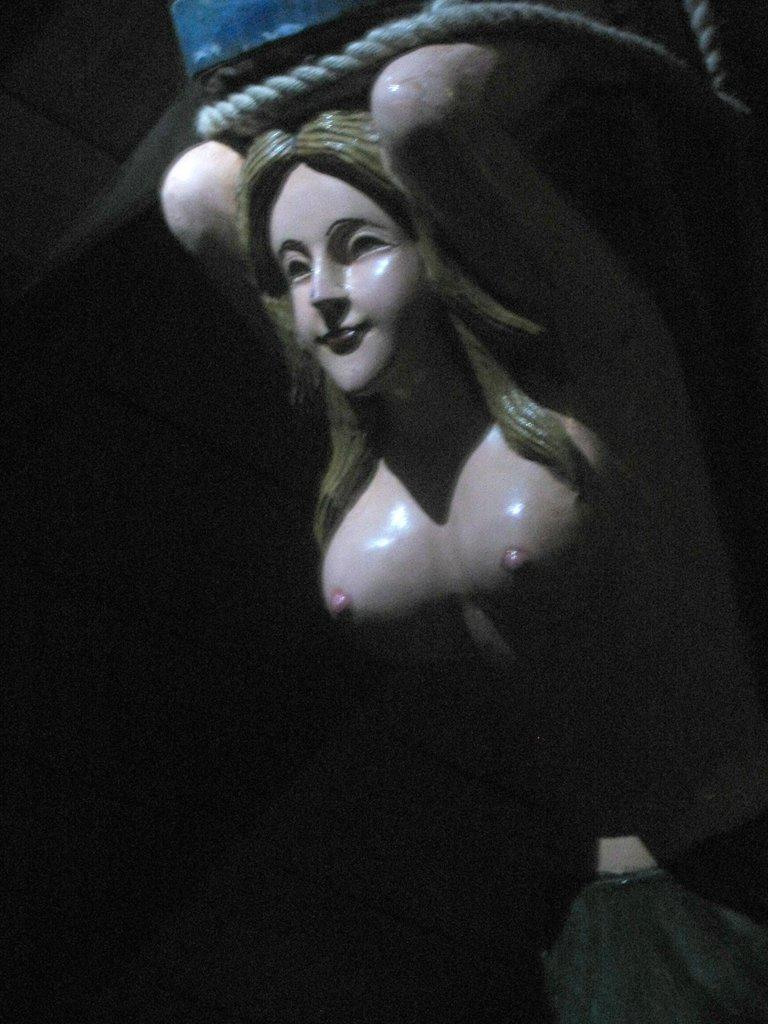What is the main subject in the center of the image? There is a statue in the center of the image. Can you describe any other elements in the image? There is a rope at the top side of the image. What type of protest is taking place in the wilderness, as seen in the image? There is no protest or wilderness present in the image; it features a statue and a rope. 